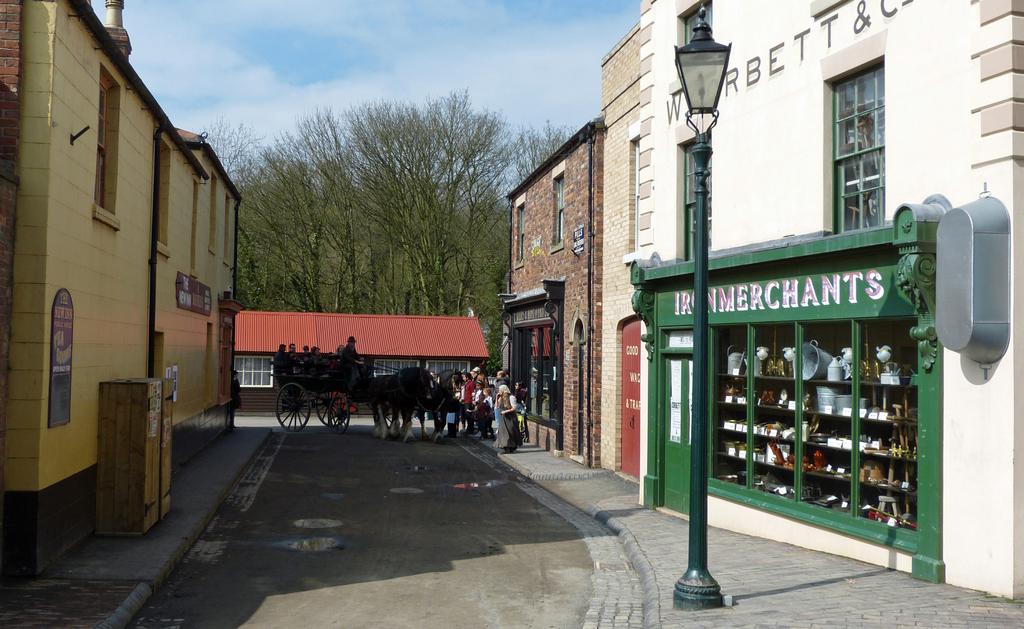What does this store sell?
Your answer should be compact. Iron. 